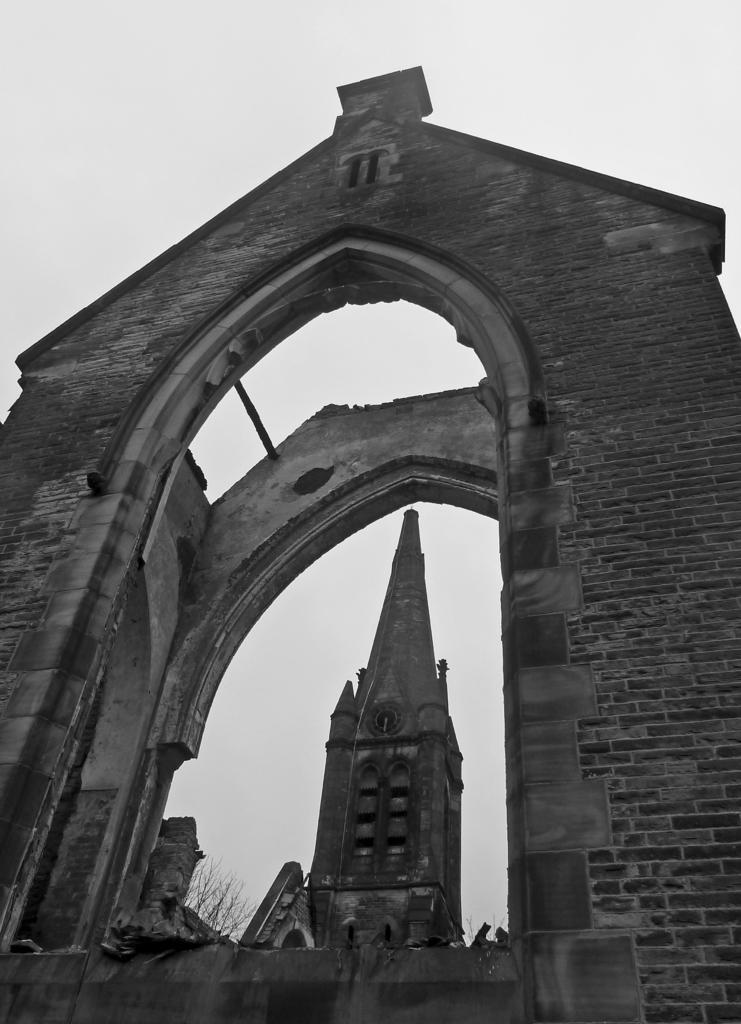How would you summarize this image in a sentence or two? This picture is clicked outside. In the foreground we can see the brick walls on which we can see the arch. In the center there is a spire. In the background we can see the sky. 